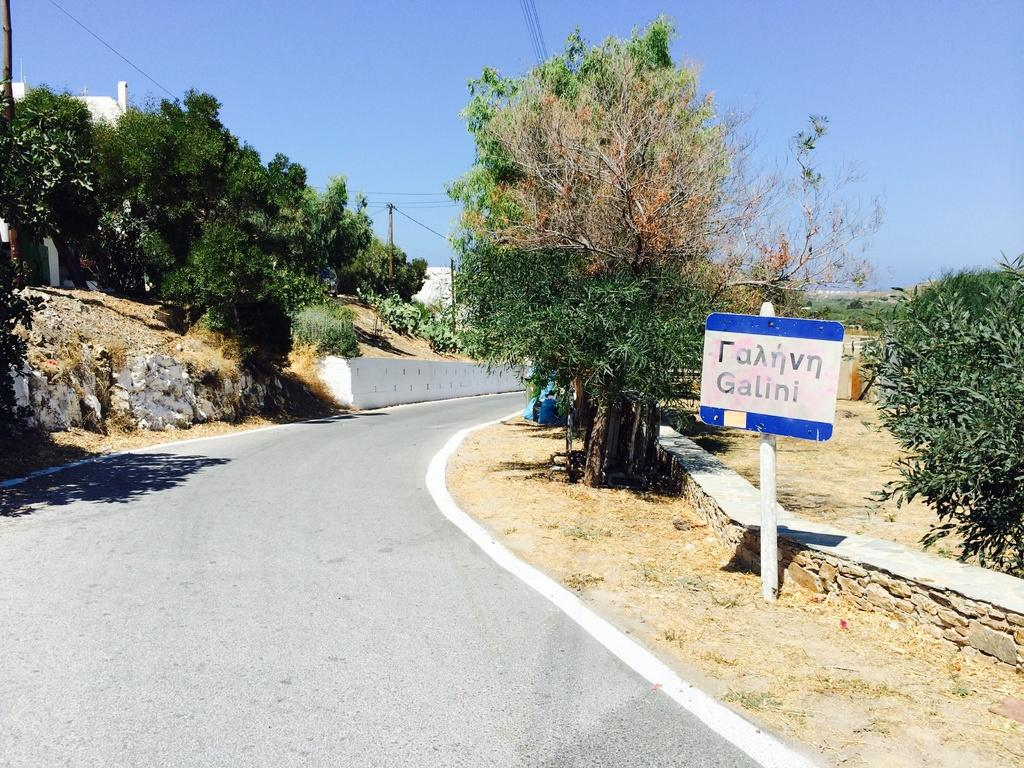What is the main feature of the image? There is a road in the image. What can be seen near the road? There are trees on the mud in the image. Is there any signage or noticeable board in the image? Yes, there is a pole with a board in the image. Can you tell me how many dogs are running along the road in the image? There are no dogs present in the image; it only features a road, trees on the mud, and a pole with a board. What type of fowl can be seen perched on the pole in the image? There are no fowl present in the image; the pole only has a board attached to it. 